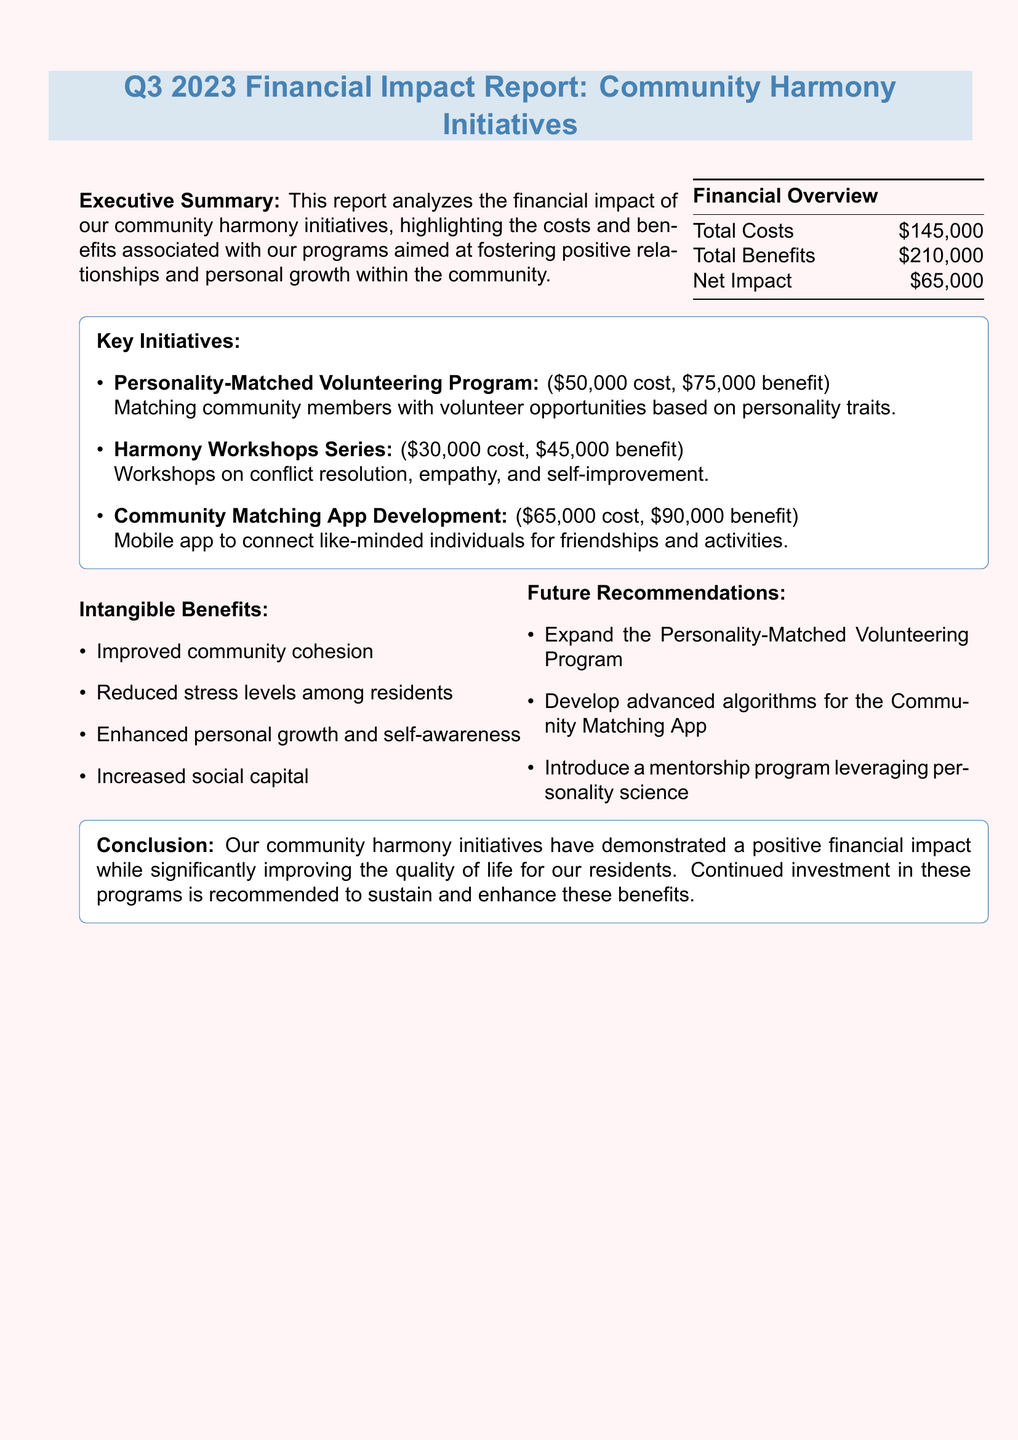What is the total cost of community harmony initiatives? The total cost is listed in the financial overview section of the document.
Answer: $145,000 What is the net impact reported? The net impact is found in the financial overview, which summarizes the overall financial results.
Answer: $65,000 (positive) What is the benefit of the Personality-Matched Volunteering Program? The benefit of this program is detailed in the key initiatives section of the document.
Answer: $75,000 What are the intangible benefits mentioned in the report? These benefits can be found under the intangible benefits section and enumerate the qualitative improvements in the community.
Answer: Improved community cohesion, Reduced stress levels among residents, Enhanced personal growth and self-awareness, Increased social capital What is one future recommendation made in the report? Future recommendations are outlined to suggest directions for the initiatives moving forward.
Answer: Expand the Personality-Matched Volunteering Program to include more local organizations What is the cost of the Community Matching App Development? The cost is specified in the key initiatives section among the financial details of each program.
Answer: $65,000 What is the total benefit from all initiatives combined? The total benefit can be calculated by summing the benefits of all key initiatives listed in the report.
Answer: $210,000 Which initiative has the highest reported cost? The key initiatives section lists the costs associated with each initiative, identifying the highest.
Answer: Community Matching App Development 